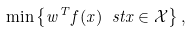Convert formula to latex. <formula><loc_0><loc_0><loc_500><loc_500>\min \left \{ w ^ { T } f ( x ) \ s t x \in \mathcal { X } \right \} ,</formula> 